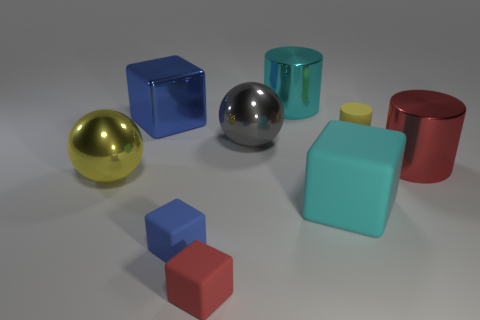Subtract all blue balls. Subtract all brown cubes. How many balls are left? 2 Add 1 red cubes. How many objects exist? 10 Subtract all cylinders. How many objects are left? 6 Subtract 0 green balls. How many objects are left? 9 Subtract all brown blocks. Subtract all big cyan cylinders. How many objects are left? 8 Add 3 red matte things. How many red matte things are left? 4 Add 1 metallic blocks. How many metallic blocks exist? 2 